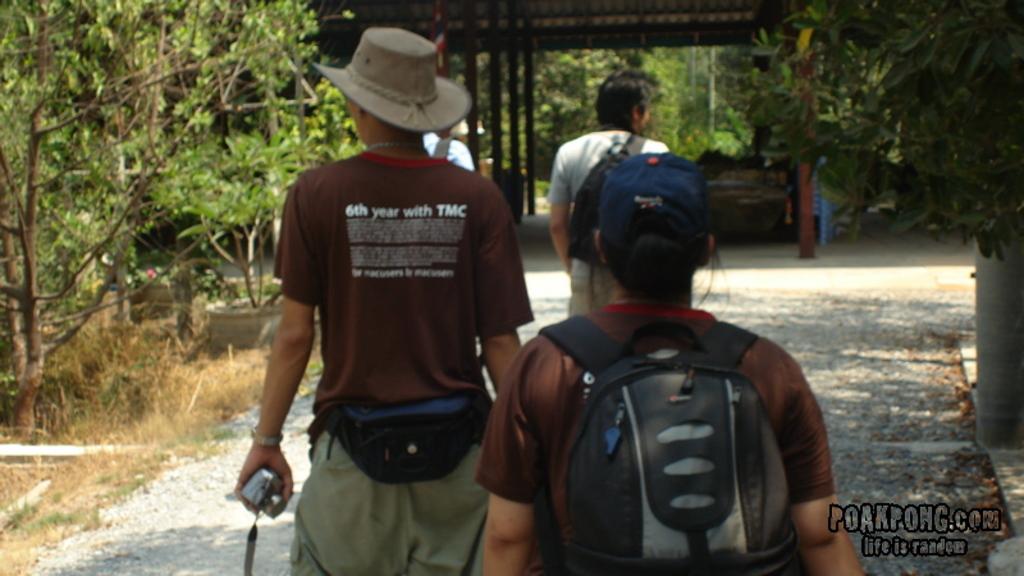What is the quote on the back of his shirt at the top?
Your answer should be compact. 6th year with tmc. 